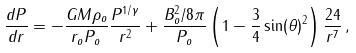<formula> <loc_0><loc_0><loc_500><loc_500>\frac { d P } { d r } = - \frac { G M \rho _ { o } } { r _ { o } P _ { o } } \frac { P ^ { 1 / \gamma } } { r ^ { 2 } } + \frac { B _ { o } ^ { 2 } / 8 \pi } { P _ { o } } \left ( 1 - \frac { 3 } { 4 } \sin ( \theta ) ^ { 2 } \right ) \frac { 2 4 } { r ^ { 7 } } \, ,</formula> 